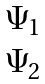Convert formula to latex. <formula><loc_0><loc_0><loc_500><loc_500>\begin{matrix} \Psi _ { 1 } \\ \Psi _ { 2 } \end{matrix}</formula> 